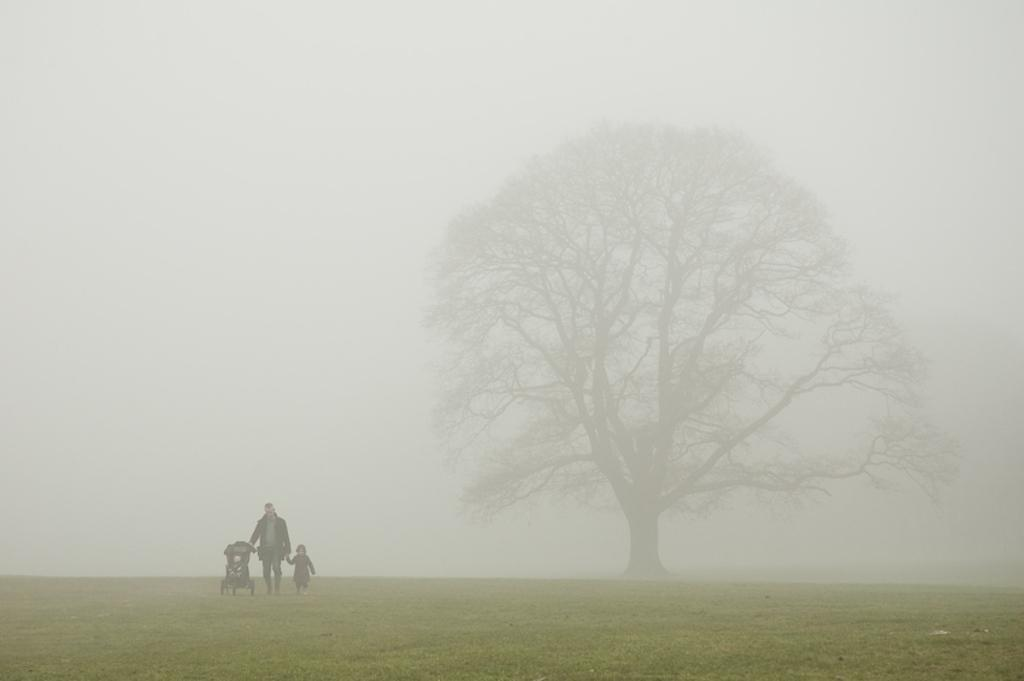Who is present in the image? There is a man in the image. What is the man doing in the image? The man is holding a kid. What object related to transportation is visible in the image? There is a stroller in the image. Where is the scene taking place? The scene is set on the ground. What type of vegetation can be seen in the image? There is a tree on the right side of the image. What is visible in the background of the image? The sky is visible in the background of the image. What type of button is the man wearing on his shirt in the image? There is no button mentioned or visible on the man's shirt in the image. What type of tank is visible in the background of the image? There is no tank present in the image; it features a man holding a kid, a stroller, a tree, and the sky in the background. 